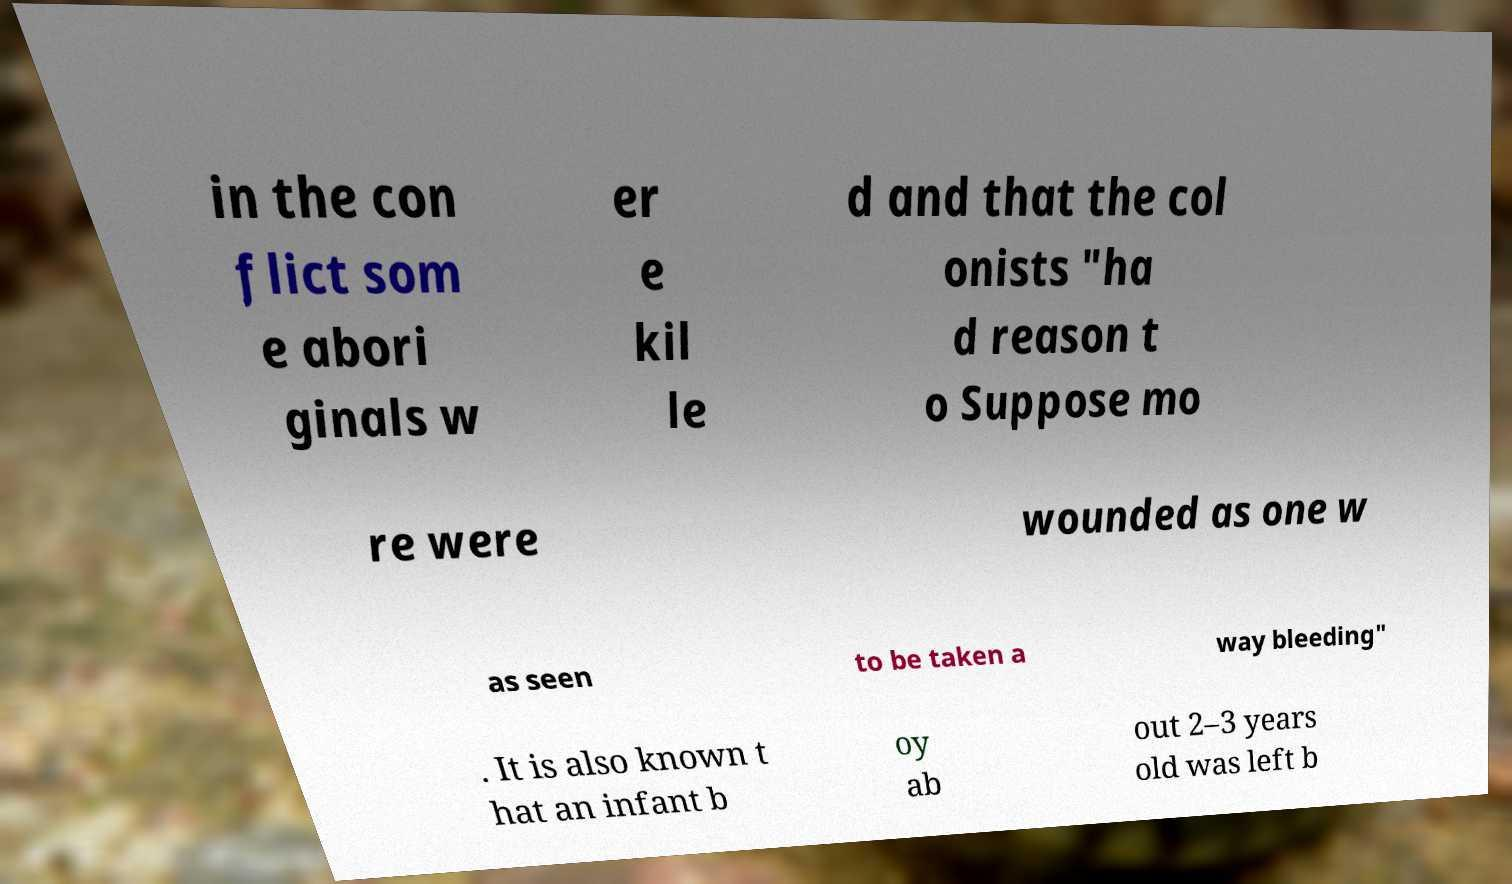There's text embedded in this image that I need extracted. Can you transcribe it verbatim? in the con flict som e abori ginals w er e kil le d and that the col onists "ha d reason t o Suppose mo re were wounded as one w as seen to be taken a way bleeding" . It is also known t hat an infant b oy ab out 2–3 years old was left b 